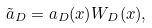<formula> <loc_0><loc_0><loc_500><loc_500>\tilde { a } _ { D } = a _ { D } ( x ) W _ { D } ( x ) ,</formula> 